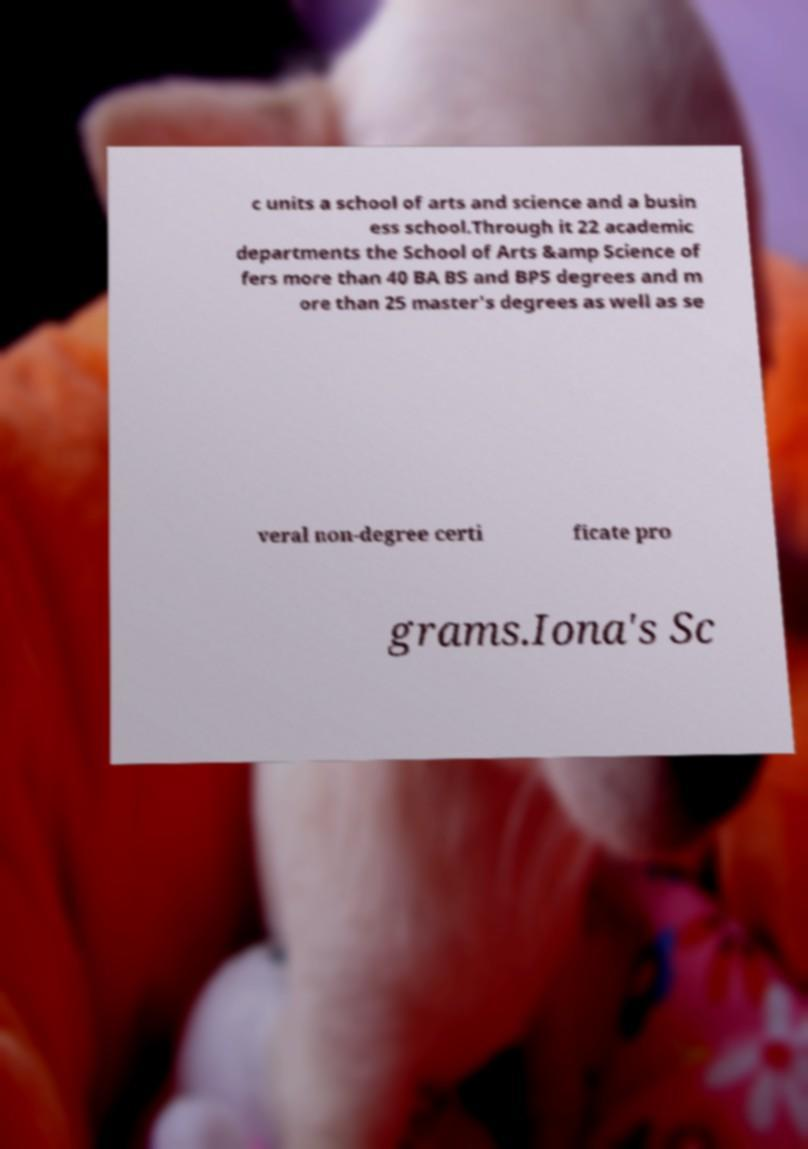I need the written content from this picture converted into text. Can you do that? c units a school of arts and science and a busin ess school.Through it 22 academic departments the School of Arts &amp Science of fers more than 40 BA BS and BPS degrees and m ore than 25 master's degrees as well as se veral non-degree certi ficate pro grams.Iona's Sc 